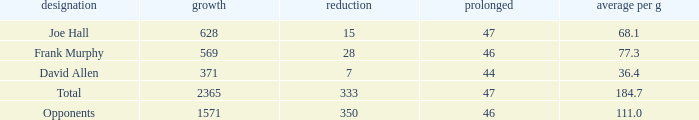How much Loss has a Gain smaller than 1571, and a Long smaller than 47, and an Avg/G of 36.4? 1.0. 